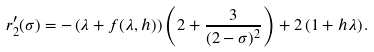<formula> <loc_0><loc_0><loc_500><loc_500>r _ { 2 } ^ { \prime } ( \sigma ) = - \left ( \lambda + f ( \lambda , h ) \right ) \left ( 2 + \frac { 3 } { ( 2 - \sigma ) ^ { 2 } } \right ) + 2 \left ( 1 + h \lambda \right ) .</formula> 